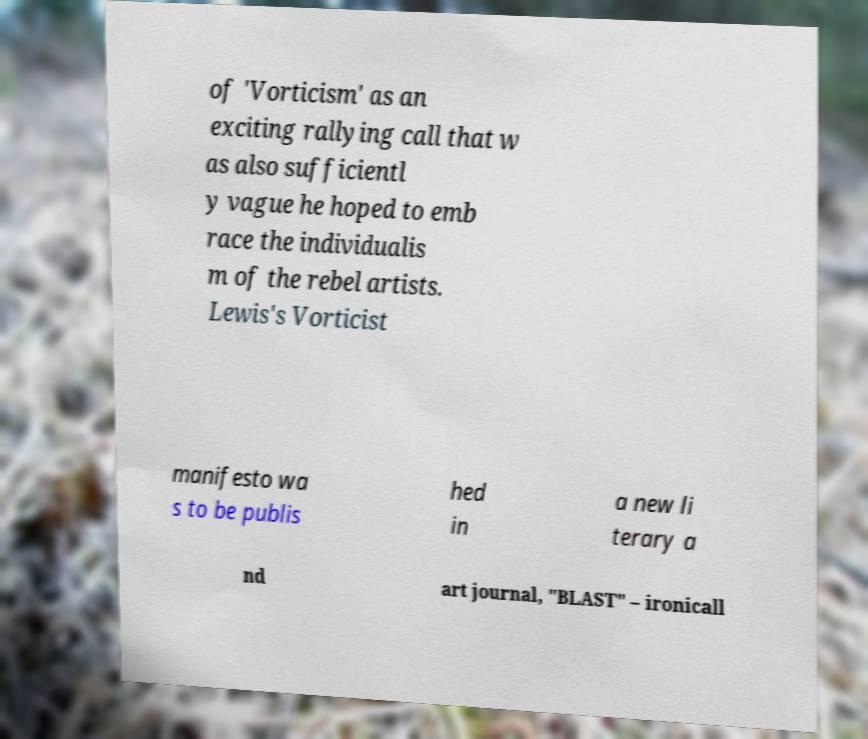For documentation purposes, I need the text within this image transcribed. Could you provide that? of 'Vorticism' as an exciting rallying call that w as also sufficientl y vague he hoped to emb race the individualis m of the rebel artists. Lewis's Vorticist manifesto wa s to be publis hed in a new li terary a nd art journal, "BLAST" – ironicall 